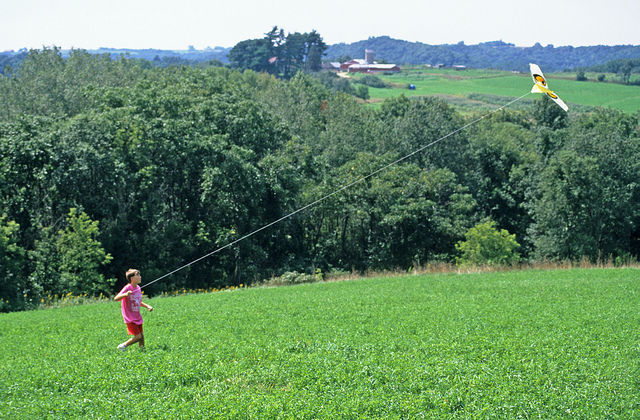How does the location and surroundings contribute to the kite flying experience? The open grassy hill with an expansive green meadow beyond the town provides an ideal space for kite flying. The lack of urban obstructions helps ensure the kite catches the wind easily for a steady rise. The nearby trees offer wind protection, preventing potential kite damage. The beautiful, serene environment enhances the enjoyment of the activity, allowing the child to fully immerse in nature. Overall, this location minimizes hazards and maximizes the pleasure of kite flying. 